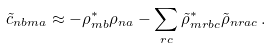<formula> <loc_0><loc_0><loc_500><loc_500>\tilde { c } _ { n b m a } \approx - \rho _ { m b } ^ { * } \rho _ { n a } - \sum _ { r c } \tilde { \rho } _ { m r b c } ^ { \ast } \tilde { \rho } _ { n r a c } \, .</formula> 